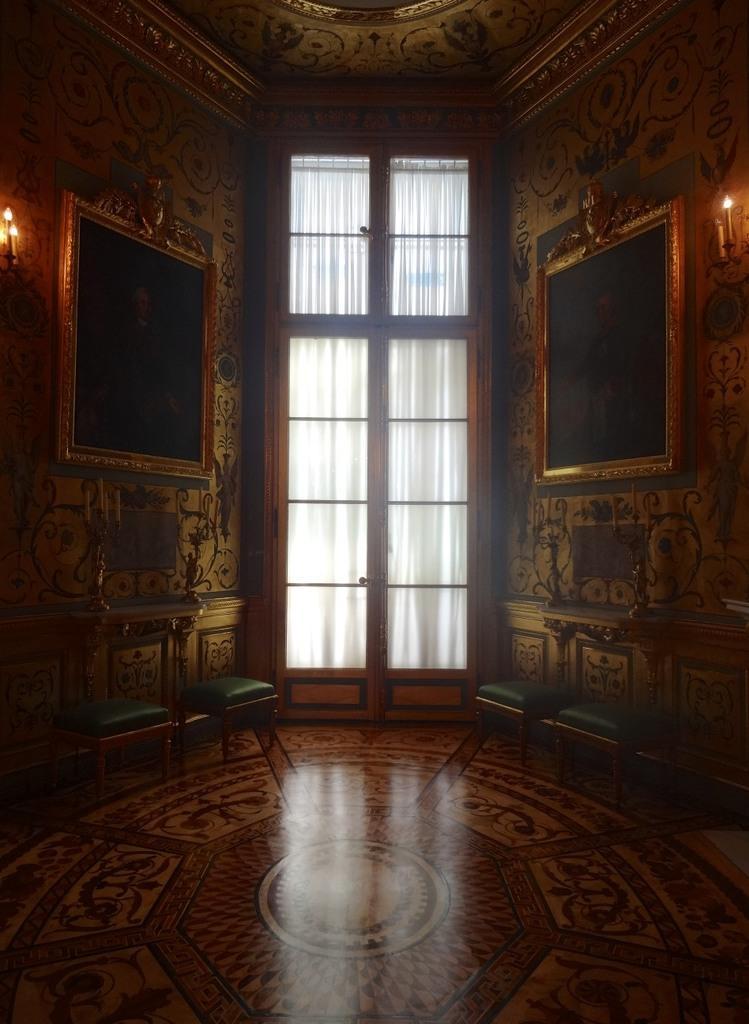How would you summarize this image in a sentence or two? This is an inside view. Where I can see some stools placed on the floor. On the right and left side of the image few boards and candles are attached to the walls. In the middle of the image I can see a curtain to the window. 